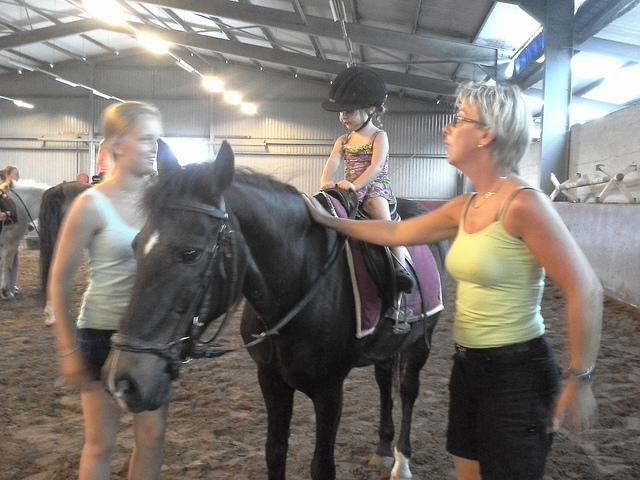Is this a riding academy?
Short answer required. Yes. What color is the saddle blanket?
Quick response, please. Purple. How old is the girl?
Be succinct. 3. Is the floor carpeted?
Concise answer only. No. 